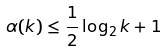<formula> <loc_0><loc_0><loc_500><loc_500>\alpha ( k ) \leq \frac { 1 } { 2 } \log _ { 2 } k + 1</formula> 